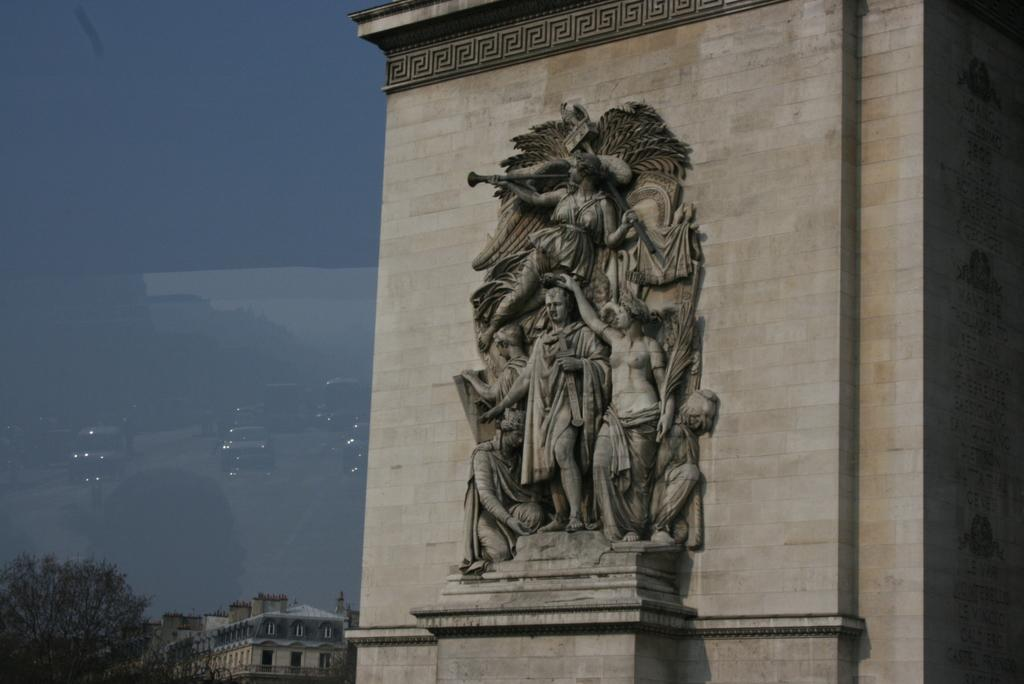What type of structures can be seen in the image? There are buildings in the image. What other object is present in the image besides the buildings? There is a statue in the image. What can be seen reflecting in the image? There is a reflection of cars in the image. What type of vegetation is visible in the image? There are trees in the image. Where is the playground located in the image? There is no playground present in the image. How many passengers are visible in the image? There are no passengers visible in the image. 